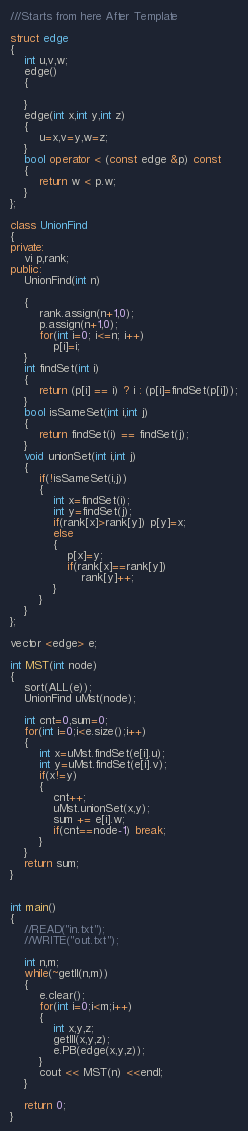<code> <loc_0><loc_0><loc_500><loc_500><_C++_>///Starts from here After Template

struct edge
{
    int u,v,w;
    edge()
    {

    }
    edge(int x,int y,int z)
    {
        u=x,v=y,w=z;
    }
    bool operator < (const edge &p) const
    {
        return w < p.w;
    }
};

class UnionFind
{
private:
    vi p,rank;
public:
    UnionFind(int n)

    {
        rank.assign(n+1,0);
        p.assign(n+1,0);
        for(int i=0; i<=n; i++)
            p[i]=i;
    }
    int findSet(int i)
    {
        return (p[i] == i) ? i : (p[i]=findSet(p[i]));
    }
    bool isSameSet(int i,int j)
    {
        return findSet(i) == findSet(j);
    }
    void unionSet(int i,int j)
    {
        if(!isSameSet(i,j))
        {
            int x=findSet(i);
            int y=findSet(j);
            if(rank[x]>rank[y]) p[y]=x;
            else
            {
                p[x]=y;
                if(rank[x]==rank[y])
                    rank[y]++;
            }
        }
    }
};

vector <edge> e;

int MST(int node)
{
    sort(ALL(e));
    UnionFind uMst(node);

    int cnt=0,sum=0;
    for(int i=0;i<e.size();i++)
    {
        int x=uMst.findSet(e[i].u);
        int y=uMst.findSet(e[i].v);
        if(x!=y)
        {
            cnt++;
            uMst.unionSet(x,y);
            sum += e[i].w;
            if(cnt==node-1) break;
        }
    }
    return sum;
}


int main()
{
    //READ("in.txt");
    //WRITE("out.txt");

    int n,m;
    while(~getII(n,m))
    {
        e.clear();
        for(int i=0;i<m;i++)
        {
            int x,y,z;
            getIII(x,y,z);
            e.PB(edge(x,y,z));
        }
        cout << MST(n) <<endl;
    }

    return 0;
}

</code> 